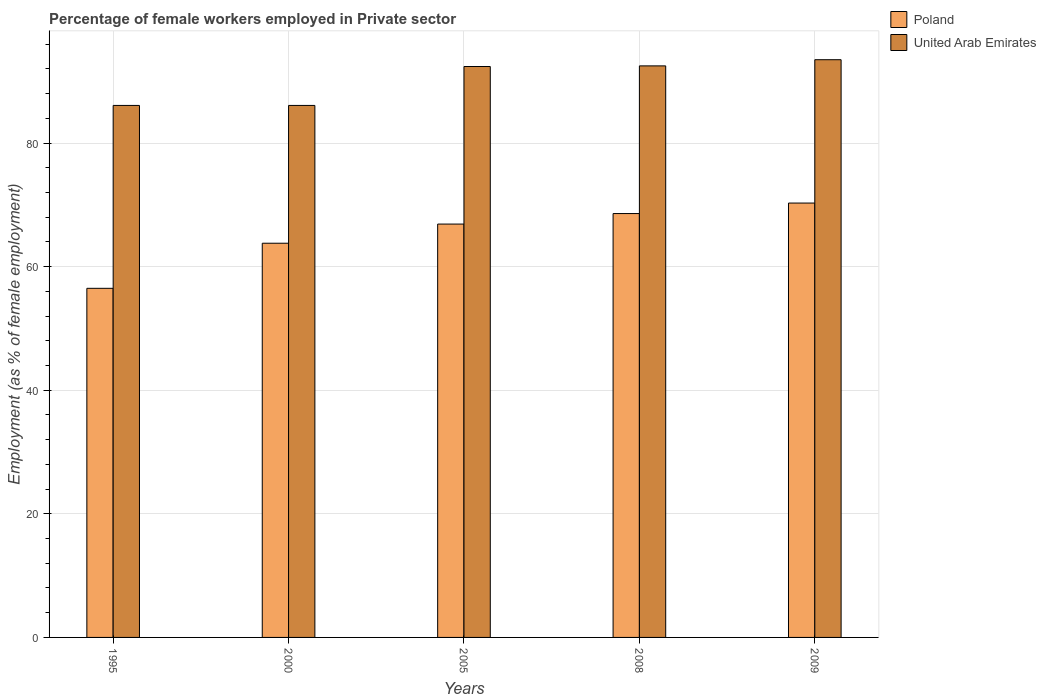How many groups of bars are there?
Make the answer very short. 5. Are the number of bars on each tick of the X-axis equal?
Your answer should be very brief. Yes. How many bars are there on the 5th tick from the left?
Your answer should be compact. 2. What is the percentage of females employed in Private sector in United Arab Emirates in 1995?
Offer a terse response. 86.1. Across all years, what is the maximum percentage of females employed in Private sector in Poland?
Provide a short and direct response. 70.3. Across all years, what is the minimum percentage of females employed in Private sector in United Arab Emirates?
Keep it short and to the point. 86.1. In which year was the percentage of females employed in Private sector in Poland minimum?
Give a very brief answer. 1995. What is the total percentage of females employed in Private sector in United Arab Emirates in the graph?
Offer a very short reply. 450.6. What is the difference between the percentage of females employed in Private sector in United Arab Emirates in 2005 and that in 2009?
Keep it short and to the point. -1.1. What is the difference between the percentage of females employed in Private sector in Poland in 2008 and the percentage of females employed in Private sector in United Arab Emirates in 2009?
Offer a terse response. -24.9. What is the average percentage of females employed in Private sector in United Arab Emirates per year?
Offer a terse response. 90.12. In the year 1995, what is the difference between the percentage of females employed in Private sector in Poland and percentage of females employed in Private sector in United Arab Emirates?
Your answer should be very brief. -29.6. In how many years, is the percentage of females employed in Private sector in United Arab Emirates greater than 12 %?
Make the answer very short. 5. What is the ratio of the percentage of females employed in Private sector in United Arab Emirates in 1995 to that in 2008?
Give a very brief answer. 0.93. What is the difference between the highest and the lowest percentage of females employed in Private sector in United Arab Emirates?
Your answer should be very brief. 7.4. What does the 2nd bar from the left in 2000 represents?
Provide a short and direct response. United Arab Emirates. Are all the bars in the graph horizontal?
Your answer should be very brief. No. Does the graph contain any zero values?
Offer a very short reply. No. Where does the legend appear in the graph?
Your response must be concise. Top right. What is the title of the graph?
Your response must be concise. Percentage of female workers employed in Private sector. Does "Sao Tome and Principe" appear as one of the legend labels in the graph?
Provide a short and direct response. No. What is the label or title of the X-axis?
Your answer should be very brief. Years. What is the label or title of the Y-axis?
Provide a succinct answer. Employment (as % of female employment). What is the Employment (as % of female employment) of Poland in 1995?
Offer a very short reply. 56.5. What is the Employment (as % of female employment) of United Arab Emirates in 1995?
Make the answer very short. 86.1. What is the Employment (as % of female employment) in Poland in 2000?
Offer a terse response. 63.8. What is the Employment (as % of female employment) in United Arab Emirates in 2000?
Your response must be concise. 86.1. What is the Employment (as % of female employment) of Poland in 2005?
Offer a terse response. 66.9. What is the Employment (as % of female employment) of United Arab Emirates in 2005?
Make the answer very short. 92.4. What is the Employment (as % of female employment) of Poland in 2008?
Ensure brevity in your answer.  68.6. What is the Employment (as % of female employment) of United Arab Emirates in 2008?
Offer a terse response. 92.5. What is the Employment (as % of female employment) in Poland in 2009?
Your response must be concise. 70.3. What is the Employment (as % of female employment) of United Arab Emirates in 2009?
Ensure brevity in your answer.  93.5. Across all years, what is the maximum Employment (as % of female employment) in Poland?
Keep it short and to the point. 70.3. Across all years, what is the maximum Employment (as % of female employment) in United Arab Emirates?
Make the answer very short. 93.5. Across all years, what is the minimum Employment (as % of female employment) in Poland?
Give a very brief answer. 56.5. Across all years, what is the minimum Employment (as % of female employment) of United Arab Emirates?
Your answer should be compact. 86.1. What is the total Employment (as % of female employment) of Poland in the graph?
Keep it short and to the point. 326.1. What is the total Employment (as % of female employment) in United Arab Emirates in the graph?
Provide a succinct answer. 450.6. What is the difference between the Employment (as % of female employment) of Poland in 1995 and that in 2000?
Your answer should be very brief. -7.3. What is the difference between the Employment (as % of female employment) of Poland in 1995 and that in 2008?
Your answer should be very brief. -12.1. What is the difference between the Employment (as % of female employment) in United Arab Emirates in 1995 and that in 2008?
Provide a succinct answer. -6.4. What is the difference between the Employment (as % of female employment) of Poland in 2000 and that in 2005?
Make the answer very short. -3.1. What is the difference between the Employment (as % of female employment) of United Arab Emirates in 2000 and that in 2005?
Provide a succinct answer. -6.3. What is the difference between the Employment (as % of female employment) of Poland in 2000 and that in 2008?
Make the answer very short. -4.8. What is the difference between the Employment (as % of female employment) of United Arab Emirates in 2000 and that in 2008?
Your answer should be compact. -6.4. What is the difference between the Employment (as % of female employment) of Poland in 2005 and that in 2009?
Make the answer very short. -3.4. What is the difference between the Employment (as % of female employment) in Poland in 1995 and the Employment (as % of female employment) in United Arab Emirates in 2000?
Give a very brief answer. -29.6. What is the difference between the Employment (as % of female employment) in Poland in 1995 and the Employment (as % of female employment) in United Arab Emirates in 2005?
Offer a very short reply. -35.9. What is the difference between the Employment (as % of female employment) of Poland in 1995 and the Employment (as % of female employment) of United Arab Emirates in 2008?
Give a very brief answer. -36. What is the difference between the Employment (as % of female employment) in Poland in 1995 and the Employment (as % of female employment) in United Arab Emirates in 2009?
Ensure brevity in your answer.  -37. What is the difference between the Employment (as % of female employment) of Poland in 2000 and the Employment (as % of female employment) of United Arab Emirates in 2005?
Provide a succinct answer. -28.6. What is the difference between the Employment (as % of female employment) of Poland in 2000 and the Employment (as % of female employment) of United Arab Emirates in 2008?
Provide a short and direct response. -28.7. What is the difference between the Employment (as % of female employment) in Poland in 2000 and the Employment (as % of female employment) in United Arab Emirates in 2009?
Offer a very short reply. -29.7. What is the difference between the Employment (as % of female employment) in Poland in 2005 and the Employment (as % of female employment) in United Arab Emirates in 2008?
Your answer should be very brief. -25.6. What is the difference between the Employment (as % of female employment) in Poland in 2005 and the Employment (as % of female employment) in United Arab Emirates in 2009?
Offer a terse response. -26.6. What is the difference between the Employment (as % of female employment) of Poland in 2008 and the Employment (as % of female employment) of United Arab Emirates in 2009?
Your answer should be compact. -24.9. What is the average Employment (as % of female employment) of Poland per year?
Provide a short and direct response. 65.22. What is the average Employment (as % of female employment) of United Arab Emirates per year?
Keep it short and to the point. 90.12. In the year 1995, what is the difference between the Employment (as % of female employment) in Poland and Employment (as % of female employment) in United Arab Emirates?
Your answer should be compact. -29.6. In the year 2000, what is the difference between the Employment (as % of female employment) in Poland and Employment (as % of female employment) in United Arab Emirates?
Ensure brevity in your answer.  -22.3. In the year 2005, what is the difference between the Employment (as % of female employment) of Poland and Employment (as % of female employment) of United Arab Emirates?
Offer a terse response. -25.5. In the year 2008, what is the difference between the Employment (as % of female employment) of Poland and Employment (as % of female employment) of United Arab Emirates?
Offer a terse response. -23.9. In the year 2009, what is the difference between the Employment (as % of female employment) in Poland and Employment (as % of female employment) in United Arab Emirates?
Give a very brief answer. -23.2. What is the ratio of the Employment (as % of female employment) in Poland in 1995 to that in 2000?
Ensure brevity in your answer.  0.89. What is the ratio of the Employment (as % of female employment) of Poland in 1995 to that in 2005?
Your response must be concise. 0.84. What is the ratio of the Employment (as % of female employment) of United Arab Emirates in 1995 to that in 2005?
Make the answer very short. 0.93. What is the ratio of the Employment (as % of female employment) in Poland in 1995 to that in 2008?
Ensure brevity in your answer.  0.82. What is the ratio of the Employment (as % of female employment) in United Arab Emirates in 1995 to that in 2008?
Ensure brevity in your answer.  0.93. What is the ratio of the Employment (as % of female employment) of Poland in 1995 to that in 2009?
Your answer should be very brief. 0.8. What is the ratio of the Employment (as % of female employment) of United Arab Emirates in 1995 to that in 2009?
Provide a short and direct response. 0.92. What is the ratio of the Employment (as % of female employment) in Poland in 2000 to that in 2005?
Keep it short and to the point. 0.95. What is the ratio of the Employment (as % of female employment) of United Arab Emirates in 2000 to that in 2005?
Offer a terse response. 0.93. What is the ratio of the Employment (as % of female employment) of United Arab Emirates in 2000 to that in 2008?
Give a very brief answer. 0.93. What is the ratio of the Employment (as % of female employment) of Poland in 2000 to that in 2009?
Your response must be concise. 0.91. What is the ratio of the Employment (as % of female employment) in United Arab Emirates in 2000 to that in 2009?
Ensure brevity in your answer.  0.92. What is the ratio of the Employment (as % of female employment) in Poland in 2005 to that in 2008?
Keep it short and to the point. 0.98. What is the ratio of the Employment (as % of female employment) in United Arab Emirates in 2005 to that in 2008?
Provide a succinct answer. 1. What is the ratio of the Employment (as % of female employment) in Poland in 2005 to that in 2009?
Your answer should be compact. 0.95. What is the ratio of the Employment (as % of female employment) in United Arab Emirates in 2005 to that in 2009?
Provide a short and direct response. 0.99. What is the ratio of the Employment (as % of female employment) in Poland in 2008 to that in 2009?
Your response must be concise. 0.98. What is the ratio of the Employment (as % of female employment) of United Arab Emirates in 2008 to that in 2009?
Offer a very short reply. 0.99. What is the difference between the highest and the second highest Employment (as % of female employment) in Poland?
Your response must be concise. 1.7. What is the difference between the highest and the lowest Employment (as % of female employment) of Poland?
Ensure brevity in your answer.  13.8. What is the difference between the highest and the lowest Employment (as % of female employment) of United Arab Emirates?
Ensure brevity in your answer.  7.4. 